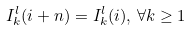Convert formula to latex. <formula><loc_0><loc_0><loc_500><loc_500>I _ { k } ^ { l } ( i + n ) = I _ { k } ^ { l } ( i ) , \, \forall k \geq 1</formula> 